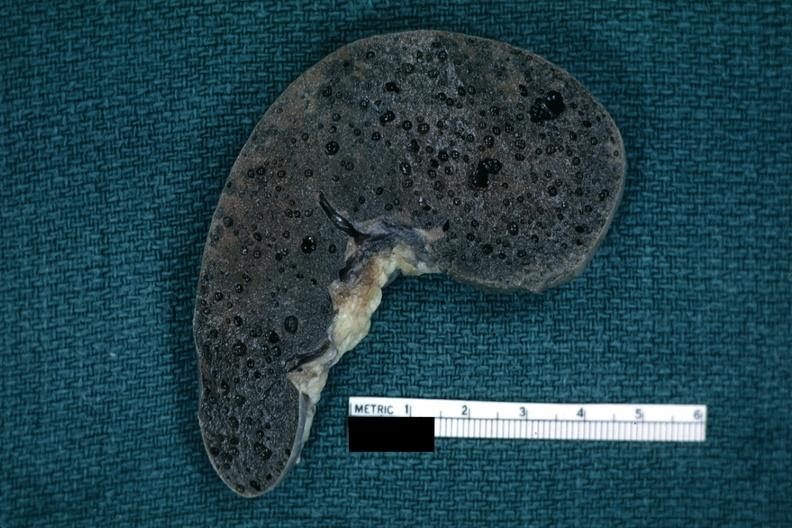does this image show fixed tissue typical swiss cheese appearance of tissue with this artefact?
Answer the question using a single word or phrase. Yes 